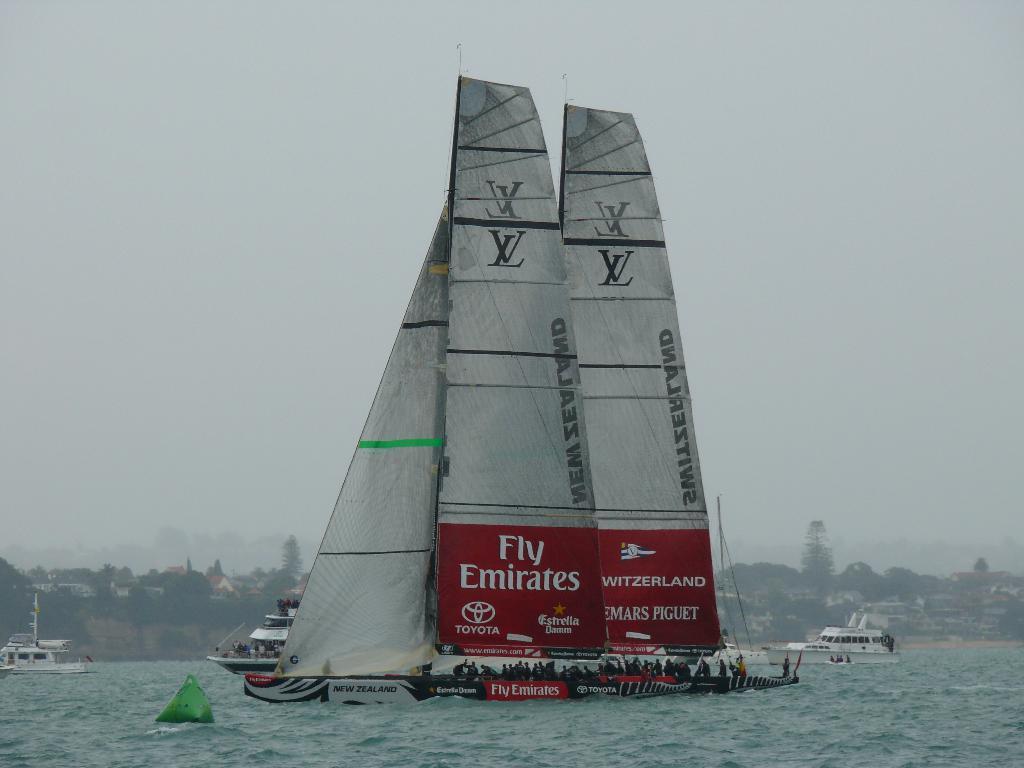Please provide a concise description of this image. Here in this picture in the front we can see a boat present in the water over there, as we can see water present all over there and we can see number of people present on the boat over there and behind that also we can see number of boats present in the water over there and in the far we can see houses and plants and trees present and we can see the sky is cloudy over there. 